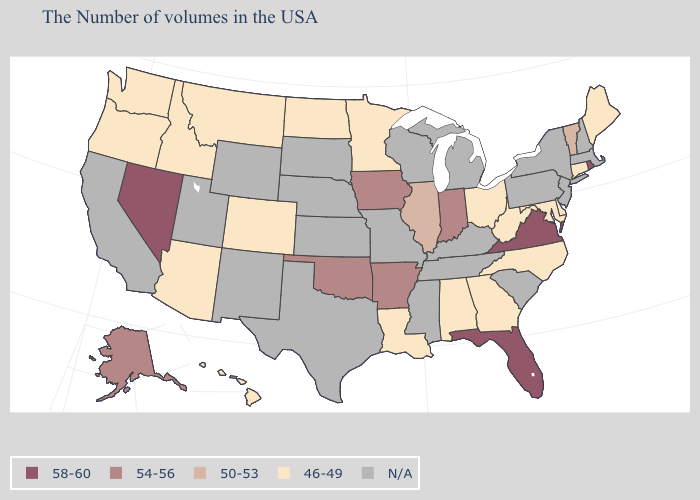Does the first symbol in the legend represent the smallest category?
Keep it brief. No. Name the states that have a value in the range 58-60?
Be succinct. Rhode Island, Virginia, Florida, Nevada. Does Oregon have the lowest value in the USA?
Write a very short answer. Yes. What is the value of Rhode Island?
Short answer required. 58-60. What is the value of Arizona?
Concise answer only. 46-49. Name the states that have a value in the range 58-60?
Short answer required. Rhode Island, Virginia, Florida, Nevada. Name the states that have a value in the range 58-60?
Answer briefly. Rhode Island, Virginia, Florida, Nevada. How many symbols are there in the legend?
Write a very short answer. 5. What is the value of Minnesota?
Short answer required. 46-49. What is the highest value in states that border North Carolina?
Give a very brief answer. 58-60. Which states hav the highest value in the Northeast?
Concise answer only. Rhode Island. Is the legend a continuous bar?
Be succinct. No. Name the states that have a value in the range 50-53?
Keep it brief. Vermont, Illinois. What is the highest value in the South ?
Be succinct. 58-60. 